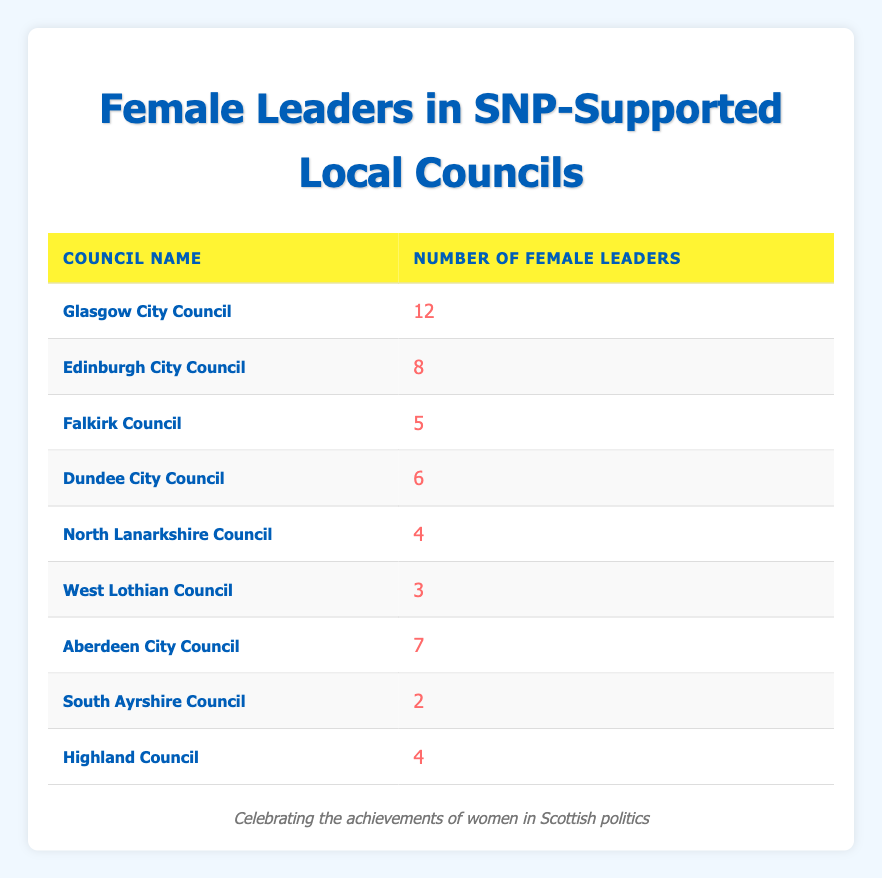What is the total number of female leaders across all councils listed? To find the total number of female leaders, we need to sum the "Number of Female Leaders" from each council: 12 (Glasgow) + 8 (Edinburgh) + 5 (Falkirk) + 6 (Dundee) + 4 (North Lanarkshire) + 3 (West Lothian) + 7 (Aberdeen) + 2 (South Ayrshire) + 4 (Highland) = 51
Answer: 51 Which council has the highest number of female leaders? By scanning the "Number of Female Leaders" column, we see that Glasgow City Council has 12 female leaders, which is higher than any other council.
Answer: Glasgow City Council Is there a council with only one female leader? Checking the table, all councils listed have either 2 or more female leaders; thus, there is no council with just one female leader.
Answer: No How many councils have four or more female leaders? To determine this, count the councils with female leaders: Glasgow (12), Edinburgh (8), Dundee (6), Falkirk (5), Aberdeen (7), and both North Lanarkshire and Highland (4). That's 6 councils.
Answer: 6 What is the average number of female leaders among these councils? First, add the total number of female leaders (51) and divide that by the number of councils (9): 51/9 = 5.67, which is the average number of female leaders per council.
Answer: 5.67 Are there more female leaders in Edinburgh City Council than in North Lanarkshire Council? Comparing the specific numbers, Edinburgh has 8 female leaders while North Lanarkshire has 4, so indeed, Edinburgh has more.
Answer: Yes How many councils have fewer than five female leaders? By checking the numbers, the councils with fewer than five female leaders are: North Lanarkshire (4), West Lothian (3), and South Ayrshire (2). This totals 3 councils.
Answer: 3 What is the difference in the number of female leaders between Glasgow City Council and South Ayrshire Council? The number of female leaders in Glasgow is 12, and in South Ayrshire, it is 2. The difference is 12 - 2 = 10.
Answer: 10 Which council has the least number of female leaders? By reviewing the table, South Ayrshire Council has the least number of female leaders, with only 2.
Answer: South Ayrshire Council 